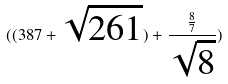<formula> <loc_0><loc_0><loc_500><loc_500>( ( 3 8 7 + \sqrt { 2 6 1 } ) + \frac { \frac { 8 } { 7 } } { \sqrt { 8 } } )</formula> 